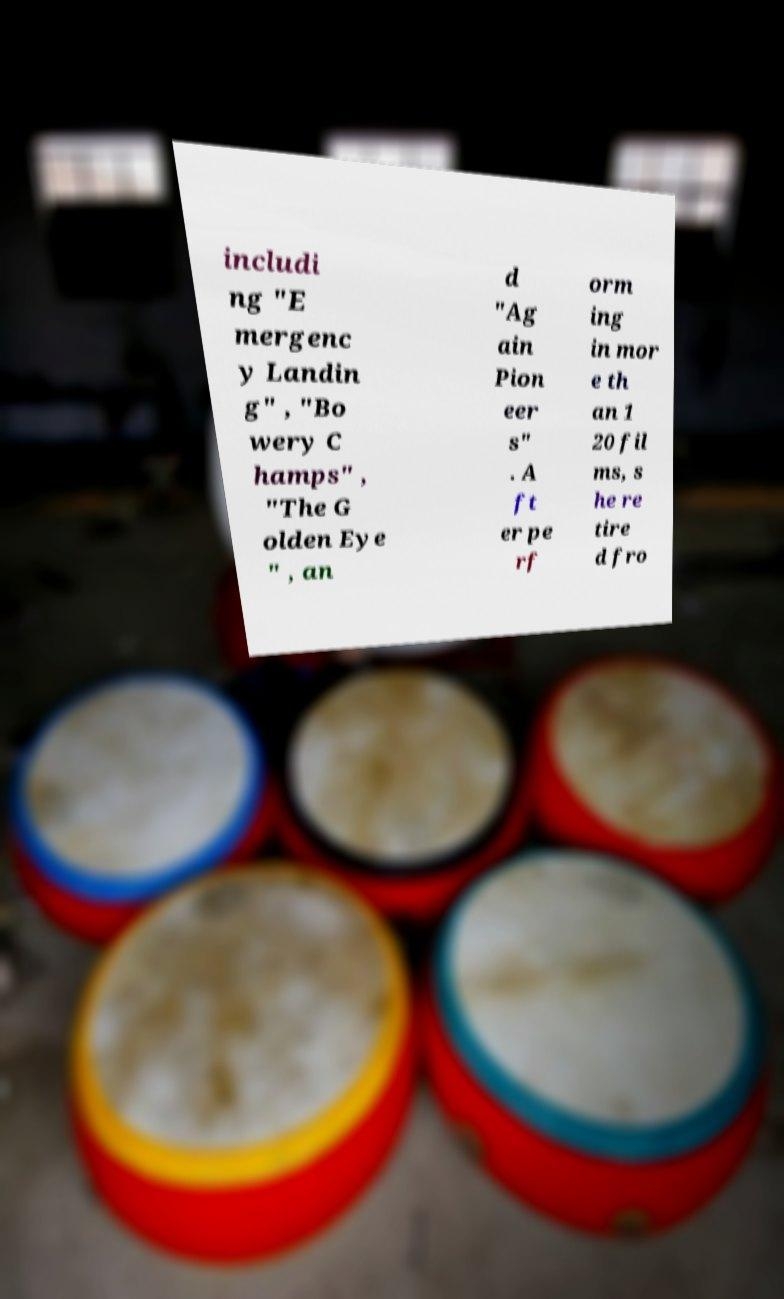Could you extract and type out the text from this image? includi ng "E mergenc y Landin g" , "Bo wery C hamps" , "The G olden Eye " , an d "Ag ain Pion eer s" . A ft er pe rf orm ing in mor e th an 1 20 fil ms, s he re tire d fro 